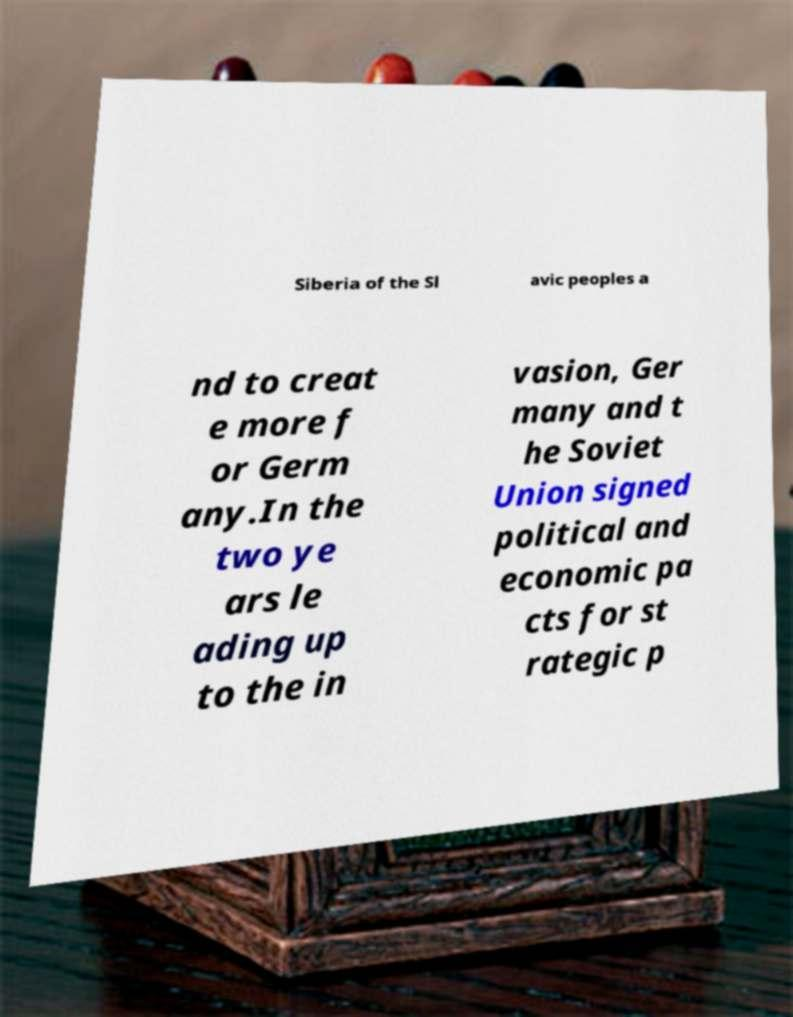Can you read and provide the text displayed in the image?This photo seems to have some interesting text. Can you extract and type it out for me? Siberia of the Sl avic peoples a nd to creat e more f or Germ any.In the two ye ars le ading up to the in vasion, Ger many and t he Soviet Union signed political and economic pa cts for st rategic p 